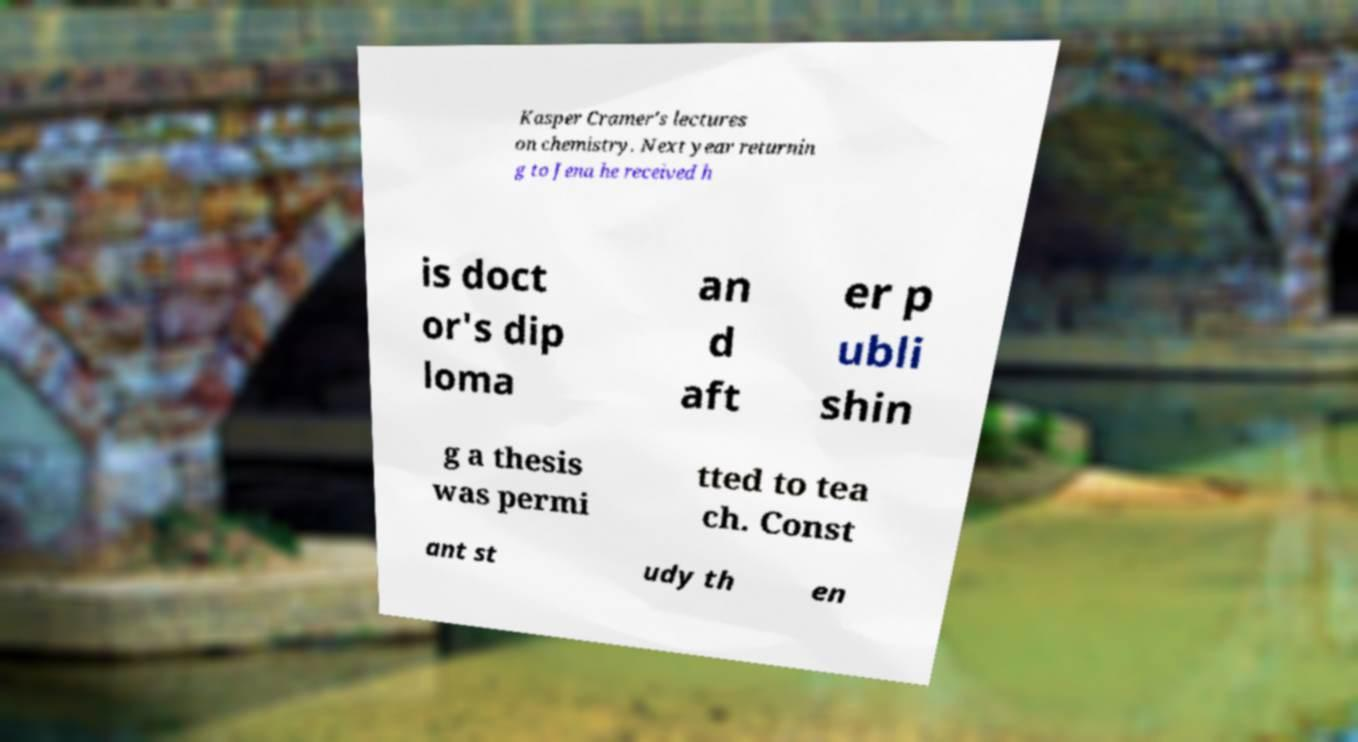Please read and relay the text visible in this image. What does it say? Kasper Cramer's lectures on chemistry. Next year returnin g to Jena he received h is doct or's dip loma an d aft er p ubli shin g a thesis was permi tted to tea ch. Const ant st udy th en 